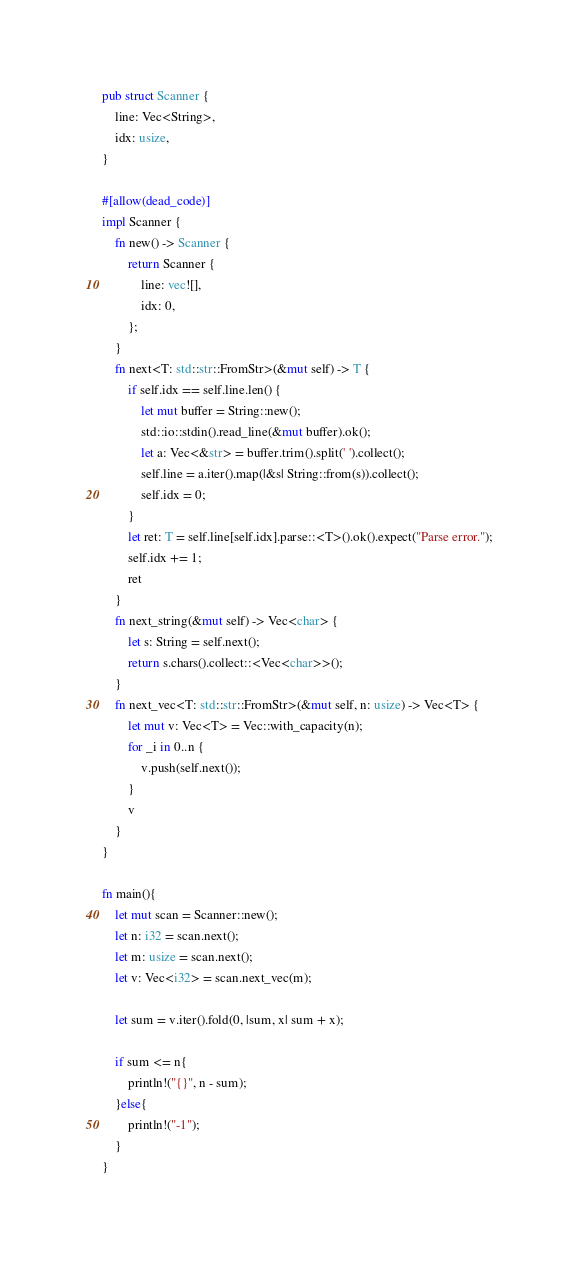Convert code to text. <code><loc_0><loc_0><loc_500><loc_500><_Rust_>pub struct Scanner {
    line: Vec<String>,
    idx: usize,
}

#[allow(dead_code)]
impl Scanner {
    fn new() -> Scanner {
        return Scanner {
            line: vec![],
            idx: 0,
        };
    }
    fn next<T: std::str::FromStr>(&mut self) -> T {
        if self.idx == self.line.len() {
            let mut buffer = String::new();
            std::io::stdin().read_line(&mut buffer).ok();
            let a: Vec<&str> = buffer.trim().split(' ').collect();
            self.line = a.iter().map(|&s| String::from(s)).collect();
            self.idx = 0;
        }
        let ret: T = self.line[self.idx].parse::<T>().ok().expect("Parse error.");
        self.idx += 1;
        ret
    }
    fn next_string(&mut self) -> Vec<char> {
        let s: String = self.next();
        return s.chars().collect::<Vec<char>>();
    }
    fn next_vec<T: std::str::FromStr>(&mut self, n: usize) -> Vec<T> {
        let mut v: Vec<T> = Vec::with_capacity(n);
        for _i in 0..n {
            v.push(self.next());
        }
        v
    }
}

fn main(){
    let mut scan = Scanner::new();
    let n: i32 = scan.next();
    let m: usize = scan.next();
    let v: Vec<i32> = scan.next_vec(m);

    let sum = v.iter().fold(0, |sum, x| sum + x);

    if sum <= n{
        println!("{}", n - sum);
    }else{
        println!("-1");
    }
}
</code> 